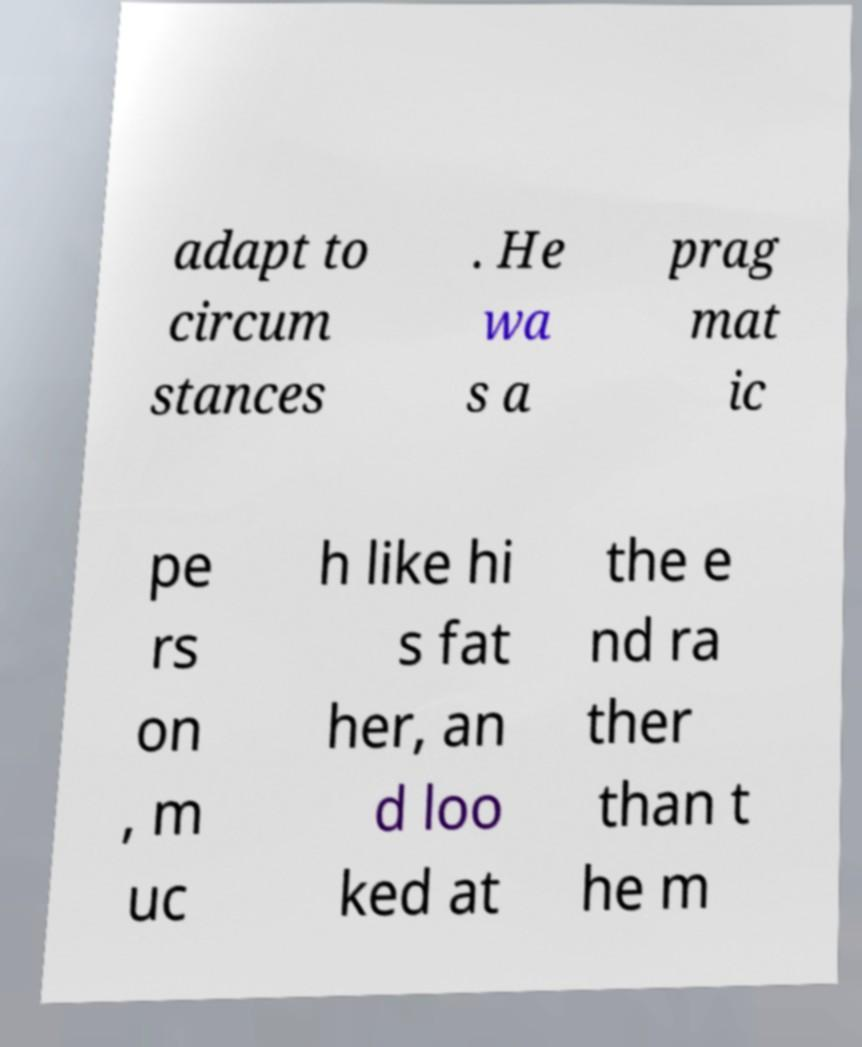Could you extract and type out the text from this image? adapt to circum stances . He wa s a prag mat ic pe rs on , m uc h like hi s fat her, an d loo ked at the e nd ra ther than t he m 